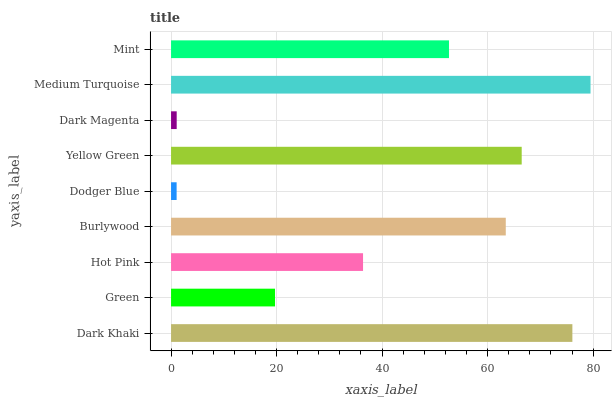Is Dodger Blue the minimum?
Answer yes or no. Yes. Is Medium Turquoise the maximum?
Answer yes or no. Yes. Is Green the minimum?
Answer yes or no. No. Is Green the maximum?
Answer yes or no. No. Is Dark Khaki greater than Green?
Answer yes or no. Yes. Is Green less than Dark Khaki?
Answer yes or no. Yes. Is Green greater than Dark Khaki?
Answer yes or no. No. Is Dark Khaki less than Green?
Answer yes or no. No. Is Mint the high median?
Answer yes or no. Yes. Is Mint the low median?
Answer yes or no. Yes. Is Green the high median?
Answer yes or no. No. Is Yellow Green the low median?
Answer yes or no. No. 